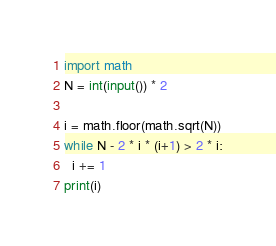Convert code to text. <code><loc_0><loc_0><loc_500><loc_500><_Python_>import math
N = int(input()) * 2

i = math.floor(math.sqrt(N))
while N - 2 * i * (i+1) > 2 * i:
  i += 1
print(i)
</code> 